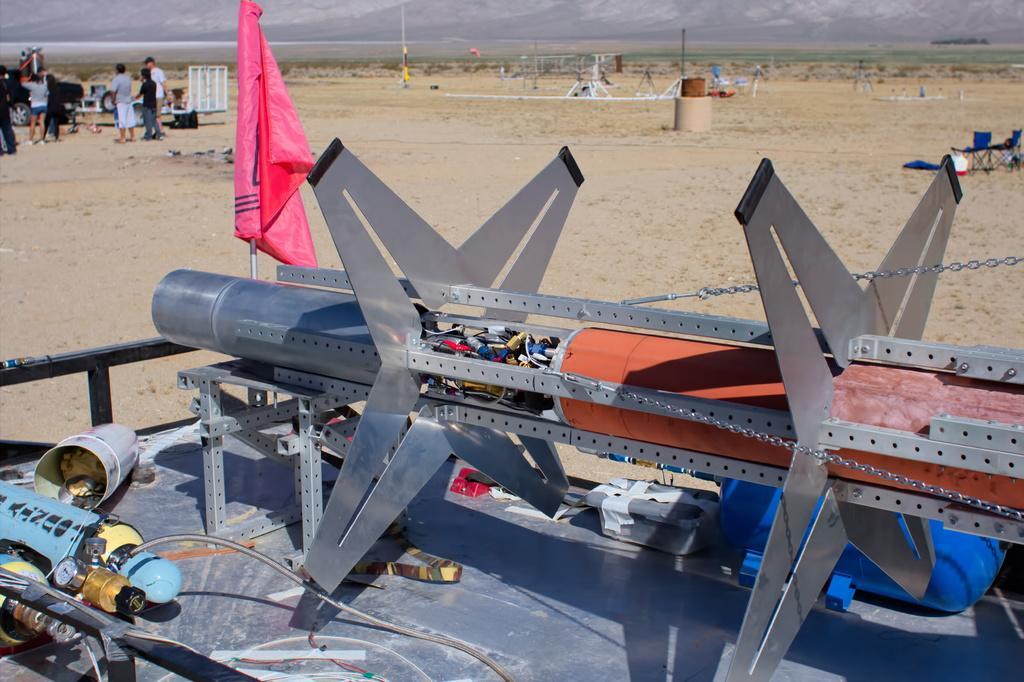In one or two sentences, can you explain what this image depicts? In this image there is some object with flag on pole, beside that there are so many people standing, also there are so many other things on the ground and some mountains. 